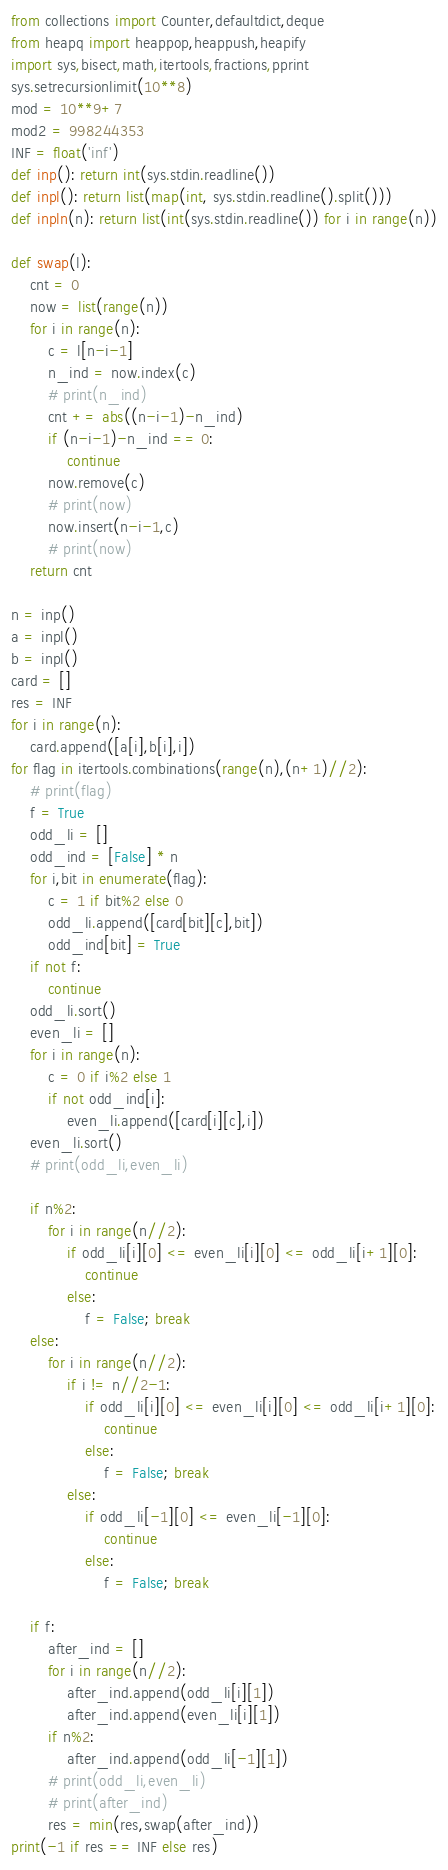<code> <loc_0><loc_0><loc_500><loc_500><_Python_>from collections import Counter,defaultdict,deque
from heapq import heappop,heappush,heapify
import sys,bisect,math,itertools,fractions,pprint
sys.setrecursionlimit(10**8)
mod = 10**9+7
mod2 = 998244353
INF = float('inf')
def inp(): return int(sys.stdin.readline())
def inpl(): return list(map(int, sys.stdin.readline().split()))
def inpln(n): return list(int(sys.stdin.readline()) for i in range(n))

def swap(l):
    cnt = 0
    now = list(range(n))
    for i in range(n):
        c = l[n-i-1]
        n_ind = now.index(c)
        # print(n_ind)
        cnt += abs((n-i-1)-n_ind)
        if (n-i-1)-n_ind == 0:
            continue
        now.remove(c)
        # print(now)
        now.insert(n-i-1,c)
        # print(now)
    return cnt

n = inp()
a = inpl()
b = inpl()
card = []
res = INF
for i in range(n):
    card.append([a[i],b[i],i])
for flag in itertools.combinations(range(n),(n+1)//2):
    # print(flag)
    f = True
    odd_li = []
    odd_ind = [False] * n
    for i,bit in enumerate(flag):
        c = 1 if bit%2 else 0
        odd_li.append([card[bit][c],bit])
        odd_ind[bit] = True
    if not f:
        continue
    odd_li.sort()
    even_li = []
    for i in range(n):
        c = 0 if i%2 else 1
        if not odd_ind[i]:
            even_li.append([card[i][c],i])
    even_li.sort()
    # print(odd_li,even_li)

    if n%2:
        for i in range(n//2):
            if odd_li[i][0] <= even_li[i][0] <= odd_li[i+1][0]:
                continue
            else:
                f = False; break
    else:
        for i in range(n//2):
            if i != n//2-1:
                if odd_li[i][0] <= even_li[i][0] <= odd_li[i+1][0]:
                    continue
                else:
                    f = False; break
            else:
                if odd_li[-1][0] <= even_li[-1][0]:
                    continue
                else:
                    f = False; break

    if f:
        after_ind = []
        for i in range(n//2):
            after_ind.append(odd_li[i][1])
            after_ind.append(even_li[i][1])
        if n%2:
            after_ind.append(odd_li[-1][1])
        # print(odd_li,even_li)
        # print(after_ind)
        res = min(res,swap(after_ind))
print(-1 if res == INF else res)</code> 